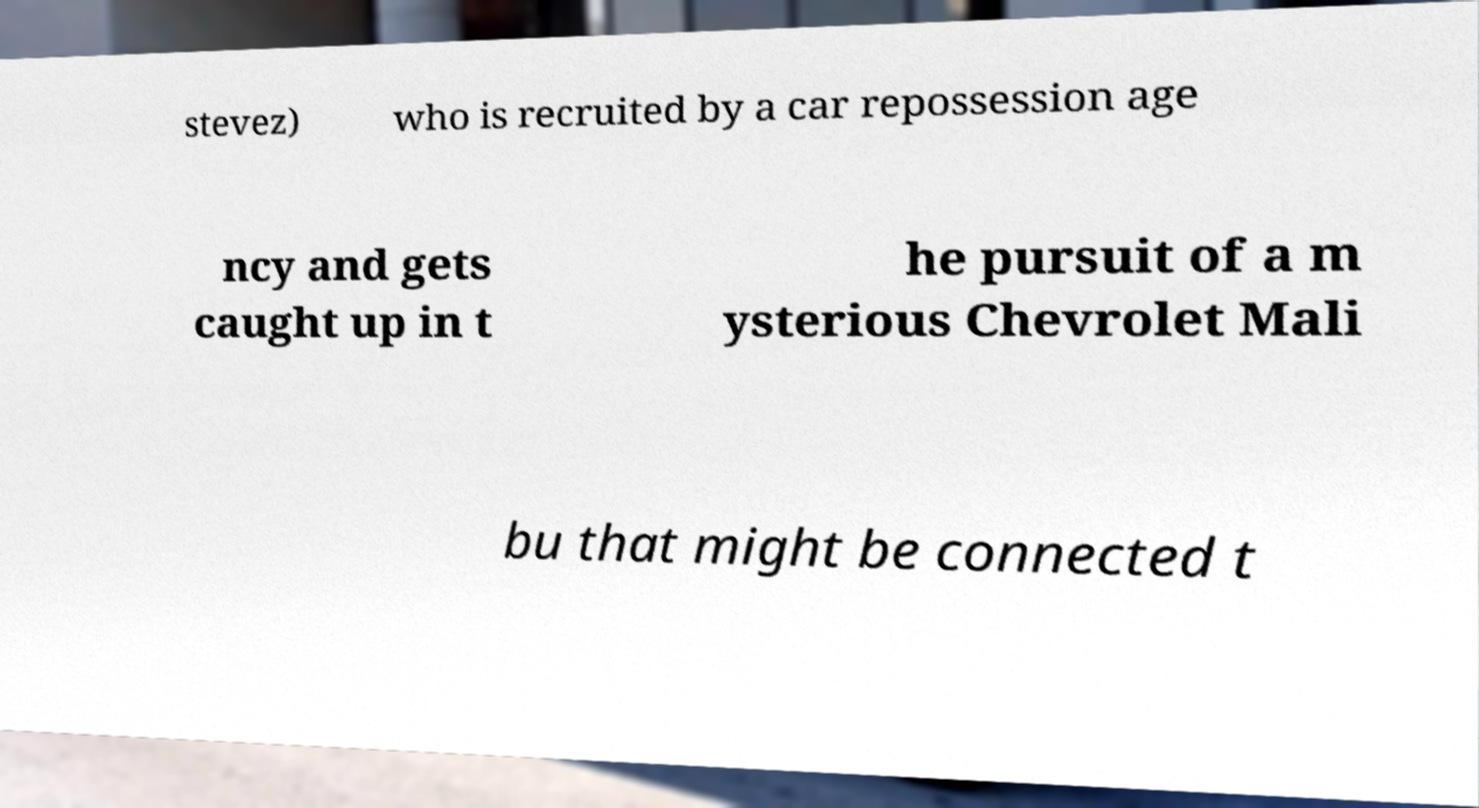Can you read and provide the text displayed in the image?This photo seems to have some interesting text. Can you extract and type it out for me? stevez) who is recruited by a car repossession age ncy and gets caught up in t he pursuit of a m ysterious Chevrolet Mali bu that might be connected t 